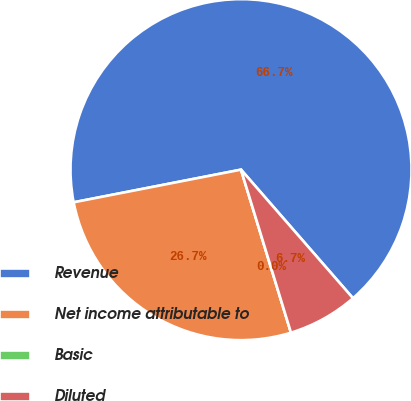Convert chart to OTSL. <chart><loc_0><loc_0><loc_500><loc_500><pie_chart><fcel>Revenue<fcel>Net income attributable to<fcel>Basic<fcel>Diluted<nl><fcel>66.67%<fcel>26.67%<fcel>0.0%<fcel>6.67%<nl></chart> 